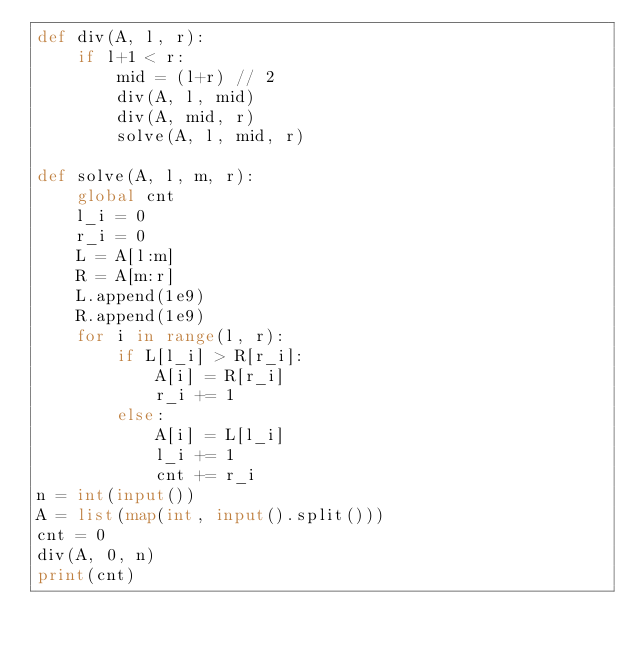Convert code to text. <code><loc_0><loc_0><loc_500><loc_500><_Python_>def div(A, l, r):
    if l+1 < r:
        mid = (l+r) // 2
        div(A, l, mid)
        div(A, mid, r)
        solve(A, l, mid, r)

def solve(A, l, m, r):
    global cnt
    l_i = 0
    r_i = 0
    L = A[l:m]
    R = A[m:r]
    L.append(1e9)
    R.append(1e9)
    for i in range(l, r):
        if L[l_i] > R[r_i]:
            A[i] = R[r_i]
            r_i += 1
        else:
            A[i] = L[l_i]
            l_i += 1
            cnt += r_i
n = int(input())
A = list(map(int, input().split()))
cnt = 0
div(A, 0, n)
print(cnt)
</code> 